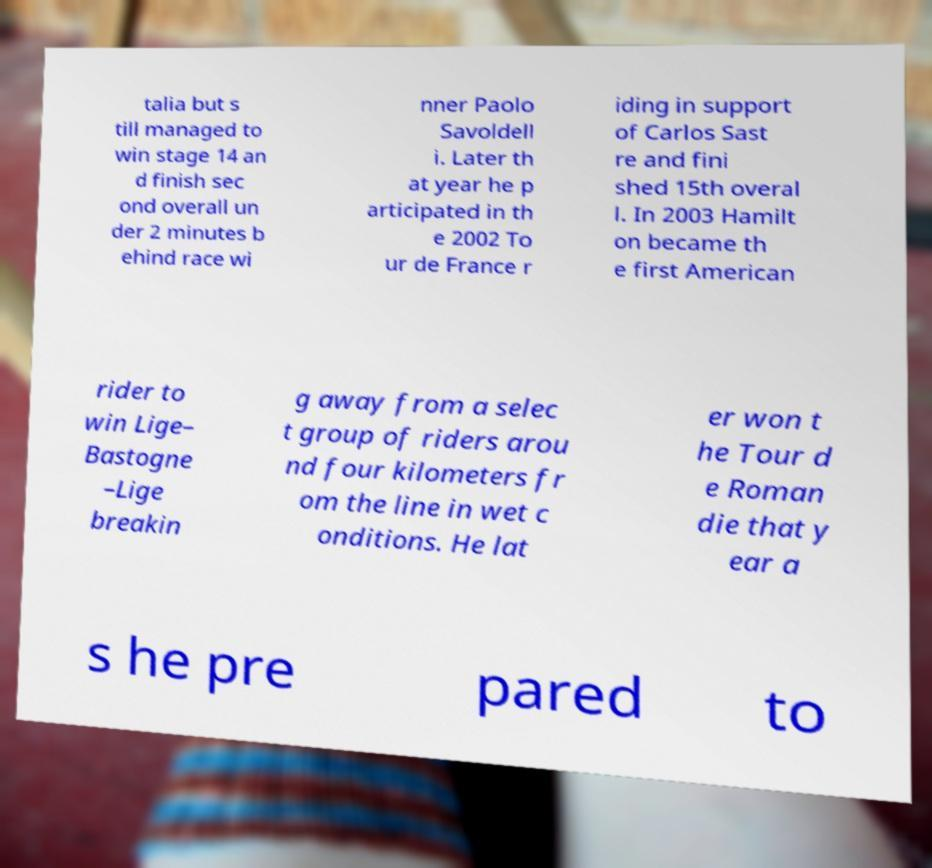Could you extract and type out the text from this image? talia but s till managed to win stage 14 an d finish sec ond overall un der 2 minutes b ehind race wi nner Paolo Savoldell i. Later th at year he p articipated in th e 2002 To ur de France r iding in support of Carlos Sast re and fini shed 15th overal l. In 2003 Hamilt on became th e first American rider to win Lige– Bastogne –Lige breakin g away from a selec t group of riders arou nd four kilometers fr om the line in wet c onditions. He lat er won t he Tour d e Roman die that y ear a s he pre pared to 